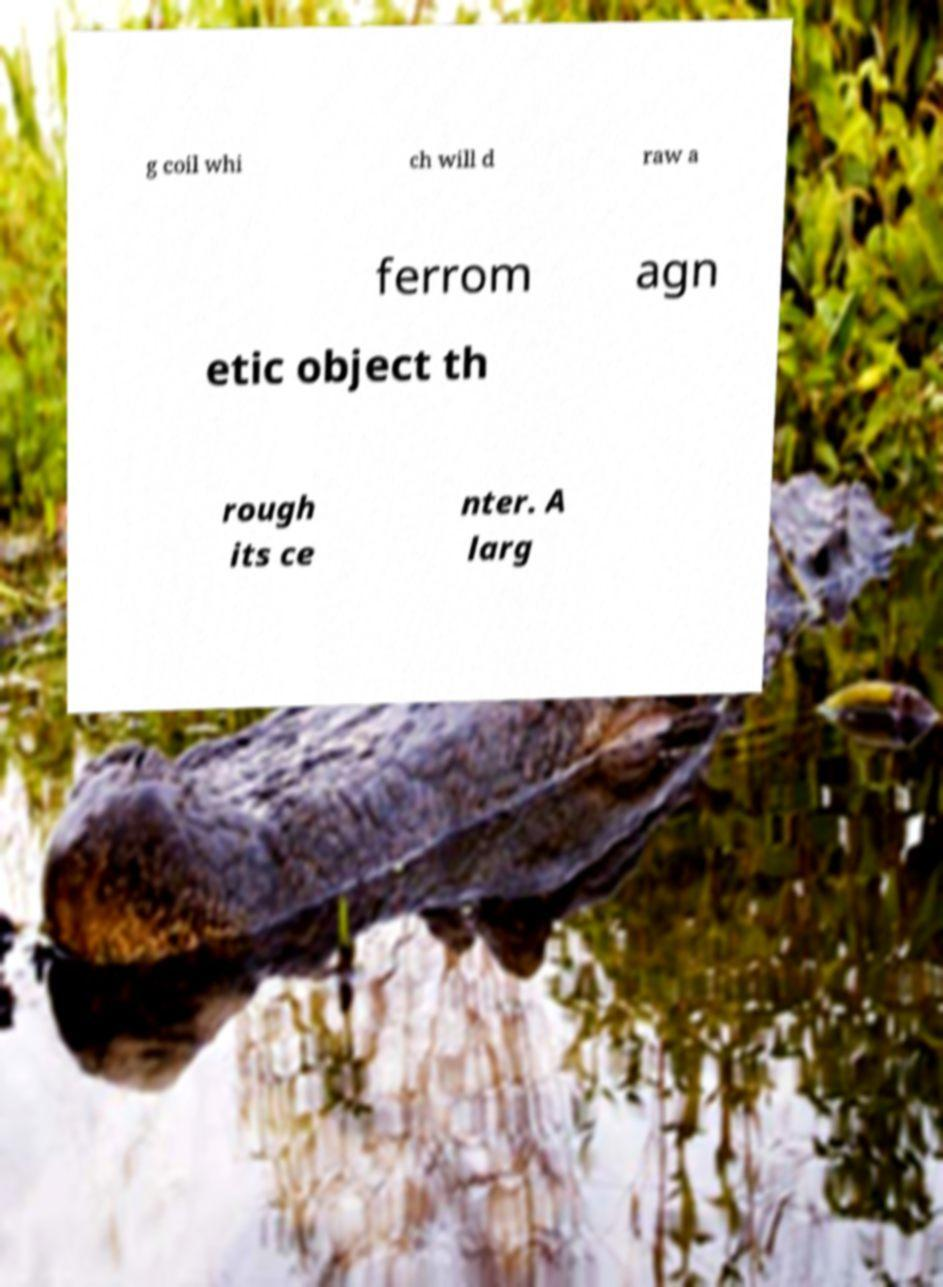I need the written content from this picture converted into text. Can you do that? g coil whi ch will d raw a ferrom agn etic object th rough its ce nter. A larg 